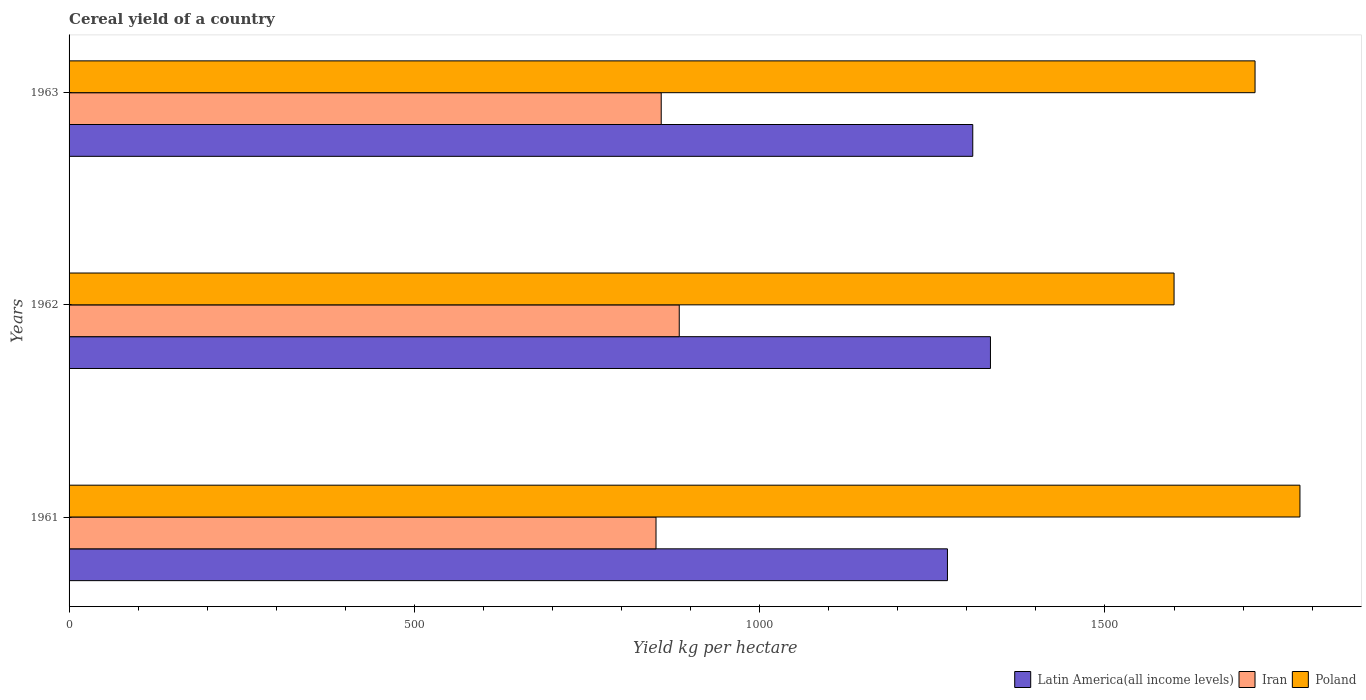How many bars are there on the 2nd tick from the top?
Provide a short and direct response. 3. What is the total cereal yield in Iran in 1961?
Make the answer very short. 849.91. Across all years, what is the maximum total cereal yield in Latin America(all income levels)?
Your answer should be very brief. 1334.2. Across all years, what is the minimum total cereal yield in Latin America(all income levels)?
Provide a short and direct response. 1271.92. In which year was the total cereal yield in Iran maximum?
Ensure brevity in your answer.  1962. What is the total total cereal yield in Latin America(all income levels) in the graph?
Your answer should be compact. 3914.71. What is the difference between the total cereal yield in Iran in 1961 and that in 1962?
Offer a very short reply. -33.64. What is the difference between the total cereal yield in Poland in 1962 and the total cereal yield in Latin America(all income levels) in 1963?
Offer a very short reply. 291.47. What is the average total cereal yield in Iran per year?
Your response must be concise. 863.64. In the year 1963, what is the difference between the total cereal yield in Poland and total cereal yield in Iran?
Your answer should be compact. 859.9. In how many years, is the total cereal yield in Poland greater than 700 kg per hectare?
Offer a terse response. 3. What is the ratio of the total cereal yield in Poland in 1961 to that in 1963?
Offer a very short reply. 1.04. Is the total cereal yield in Iran in 1962 less than that in 1963?
Your answer should be very brief. No. What is the difference between the highest and the second highest total cereal yield in Poland?
Keep it short and to the point. 65.02. What is the difference between the highest and the lowest total cereal yield in Iran?
Provide a short and direct response. 33.64. Is the sum of the total cereal yield in Poland in 1962 and 1963 greater than the maximum total cereal yield in Latin America(all income levels) across all years?
Offer a very short reply. Yes. What does the 3rd bar from the top in 1962 represents?
Your answer should be very brief. Latin America(all income levels). What does the 3rd bar from the bottom in 1962 represents?
Provide a short and direct response. Poland. Is it the case that in every year, the sum of the total cereal yield in Poland and total cereal yield in Latin America(all income levels) is greater than the total cereal yield in Iran?
Ensure brevity in your answer.  Yes. How many bars are there?
Provide a succinct answer. 9. Are all the bars in the graph horizontal?
Offer a terse response. Yes. Does the graph contain any zero values?
Keep it short and to the point. No. Does the graph contain grids?
Offer a terse response. No. What is the title of the graph?
Provide a succinct answer. Cereal yield of a country. Does "High income" appear as one of the legend labels in the graph?
Ensure brevity in your answer.  No. What is the label or title of the X-axis?
Ensure brevity in your answer.  Yield kg per hectare. What is the Yield kg per hectare in Latin America(all income levels) in 1961?
Offer a very short reply. 1271.92. What is the Yield kg per hectare of Iran in 1961?
Make the answer very short. 849.91. What is the Yield kg per hectare in Poland in 1961?
Keep it short and to the point. 1782.35. What is the Yield kg per hectare of Latin America(all income levels) in 1962?
Your response must be concise. 1334.2. What is the Yield kg per hectare of Iran in 1962?
Your response must be concise. 883.55. What is the Yield kg per hectare in Poland in 1962?
Ensure brevity in your answer.  1600.06. What is the Yield kg per hectare in Latin America(all income levels) in 1963?
Offer a terse response. 1308.59. What is the Yield kg per hectare in Iran in 1963?
Provide a succinct answer. 857.44. What is the Yield kg per hectare of Poland in 1963?
Provide a succinct answer. 1717.34. Across all years, what is the maximum Yield kg per hectare of Latin America(all income levels)?
Ensure brevity in your answer.  1334.2. Across all years, what is the maximum Yield kg per hectare in Iran?
Offer a very short reply. 883.55. Across all years, what is the maximum Yield kg per hectare of Poland?
Ensure brevity in your answer.  1782.35. Across all years, what is the minimum Yield kg per hectare in Latin America(all income levels)?
Ensure brevity in your answer.  1271.92. Across all years, what is the minimum Yield kg per hectare of Iran?
Provide a succinct answer. 849.91. Across all years, what is the minimum Yield kg per hectare of Poland?
Ensure brevity in your answer.  1600.06. What is the total Yield kg per hectare of Latin America(all income levels) in the graph?
Your response must be concise. 3914.71. What is the total Yield kg per hectare in Iran in the graph?
Your answer should be very brief. 2590.91. What is the total Yield kg per hectare of Poland in the graph?
Keep it short and to the point. 5099.75. What is the difference between the Yield kg per hectare of Latin America(all income levels) in 1961 and that in 1962?
Your answer should be very brief. -62.28. What is the difference between the Yield kg per hectare of Iran in 1961 and that in 1962?
Provide a succinct answer. -33.64. What is the difference between the Yield kg per hectare of Poland in 1961 and that in 1962?
Your answer should be compact. 182.29. What is the difference between the Yield kg per hectare in Latin America(all income levels) in 1961 and that in 1963?
Offer a very short reply. -36.67. What is the difference between the Yield kg per hectare of Iran in 1961 and that in 1963?
Your answer should be compact. -7.53. What is the difference between the Yield kg per hectare in Poland in 1961 and that in 1963?
Make the answer very short. 65.02. What is the difference between the Yield kg per hectare of Latin America(all income levels) in 1962 and that in 1963?
Provide a short and direct response. 25.62. What is the difference between the Yield kg per hectare in Iran in 1962 and that in 1963?
Provide a short and direct response. 26.11. What is the difference between the Yield kg per hectare in Poland in 1962 and that in 1963?
Offer a very short reply. -117.28. What is the difference between the Yield kg per hectare of Latin America(all income levels) in 1961 and the Yield kg per hectare of Iran in 1962?
Offer a terse response. 388.37. What is the difference between the Yield kg per hectare in Latin America(all income levels) in 1961 and the Yield kg per hectare in Poland in 1962?
Your answer should be compact. -328.14. What is the difference between the Yield kg per hectare of Iran in 1961 and the Yield kg per hectare of Poland in 1962?
Your response must be concise. -750.14. What is the difference between the Yield kg per hectare in Latin America(all income levels) in 1961 and the Yield kg per hectare in Iran in 1963?
Your answer should be very brief. 414.48. What is the difference between the Yield kg per hectare of Latin America(all income levels) in 1961 and the Yield kg per hectare of Poland in 1963?
Make the answer very short. -445.42. What is the difference between the Yield kg per hectare of Iran in 1961 and the Yield kg per hectare of Poland in 1963?
Offer a terse response. -867.42. What is the difference between the Yield kg per hectare of Latin America(all income levels) in 1962 and the Yield kg per hectare of Iran in 1963?
Keep it short and to the point. 476.76. What is the difference between the Yield kg per hectare in Latin America(all income levels) in 1962 and the Yield kg per hectare in Poland in 1963?
Ensure brevity in your answer.  -383.14. What is the difference between the Yield kg per hectare of Iran in 1962 and the Yield kg per hectare of Poland in 1963?
Your answer should be very brief. -833.78. What is the average Yield kg per hectare of Latin America(all income levels) per year?
Provide a short and direct response. 1304.9. What is the average Yield kg per hectare of Iran per year?
Make the answer very short. 863.64. What is the average Yield kg per hectare of Poland per year?
Provide a short and direct response. 1699.92. In the year 1961, what is the difference between the Yield kg per hectare of Latin America(all income levels) and Yield kg per hectare of Iran?
Offer a very short reply. 422.01. In the year 1961, what is the difference between the Yield kg per hectare in Latin America(all income levels) and Yield kg per hectare in Poland?
Make the answer very short. -510.43. In the year 1961, what is the difference between the Yield kg per hectare in Iran and Yield kg per hectare in Poland?
Your response must be concise. -932.44. In the year 1962, what is the difference between the Yield kg per hectare in Latin America(all income levels) and Yield kg per hectare in Iran?
Offer a terse response. 450.65. In the year 1962, what is the difference between the Yield kg per hectare of Latin America(all income levels) and Yield kg per hectare of Poland?
Your answer should be compact. -265.86. In the year 1962, what is the difference between the Yield kg per hectare of Iran and Yield kg per hectare of Poland?
Offer a terse response. -716.51. In the year 1963, what is the difference between the Yield kg per hectare in Latin America(all income levels) and Yield kg per hectare in Iran?
Provide a succinct answer. 451.15. In the year 1963, what is the difference between the Yield kg per hectare in Latin America(all income levels) and Yield kg per hectare in Poland?
Provide a short and direct response. -408.75. In the year 1963, what is the difference between the Yield kg per hectare of Iran and Yield kg per hectare of Poland?
Provide a short and direct response. -859.9. What is the ratio of the Yield kg per hectare in Latin America(all income levels) in 1961 to that in 1962?
Provide a succinct answer. 0.95. What is the ratio of the Yield kg per hectare of Iran in 1961 to that in 1962?
Provide a succinct answer. 0.96. What is the ratio of the Yield kg per hectare of Poland in 1961 to that in 1962?
Make the answer very short. 1.11. What is the ratio of the Yield kg per hectare of Latin America(all income levels) in 1961 to that in 1963?
Offer a terse response. 0.97. What is the ratio of the Yield kg per hectare of Iran in 1961 to that in 1963?
Give a very brief answer. 0.99. What is the ratio of the Yield kg per hectare in Poland in 1961 to that in 1963?
Keep it short and to the point. 1.04. What is the ratio of the Yield kg per hectare of Latin America(all income levels) in 1962 to that in 1963?
Ensure brevity in your answer.  1.02. What is the ratio of the Yield kg per hectare of Iran in 1962 to that in 1963?
Give a very brief answer. 1.03. What is the ratio of the Yield kg per hectare in Poland in 1962 to that in 1963?
Ensure brevity in your answer.  0.93. What is the difference between the highest and the second highest Yield kg per hectare of Latin America(all income levels)?
Provide a short and direct response. 25.62. What is the difference between the highest and the second highest Yield kg per hectare in Iran?
Your answer should be compact. 26.11. What is the difference between the highest and the second highest Yield kg per hectare in Poland?
Provide a succinct answer. 65.02. What is the difference between the highest and the lowest Yield kg per hectare of Latin America(all income levels)?
Offer a very short reply. 62.28. What is the difference between the highest and the lowest Yield kg per hectare of Iran?
Provide a succinct answer. 33.64. What is the difference between the highest and the lowest Yield kg per hectare of Poland?
Your answer should be compact. 182.29. 